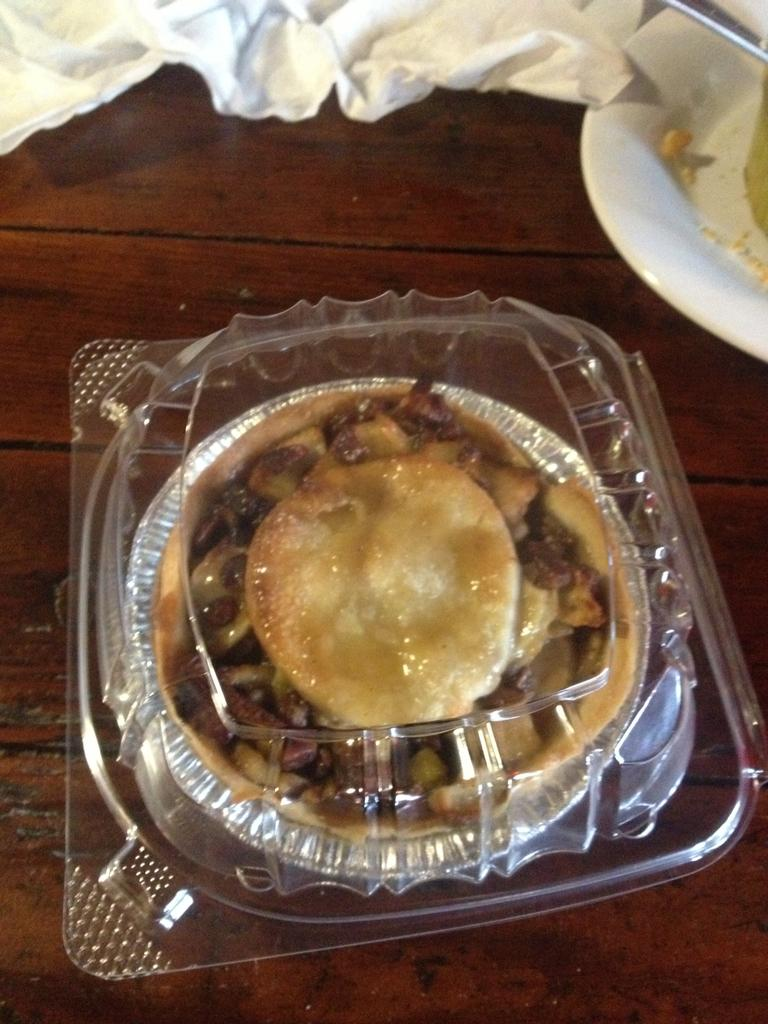What is inside the container that can be seen in the image? There is food in a container in the image. What type of surface is present in the image? There is a wooden surface in the image. What material is visible in the image? There is cloth visible in the image. Can you describe the container with the object in it? There is a white-colored container with an object in the image. What type of bells can be heard ringing in the image? There are no bells present in the image, and therefore no sound can be heard. 